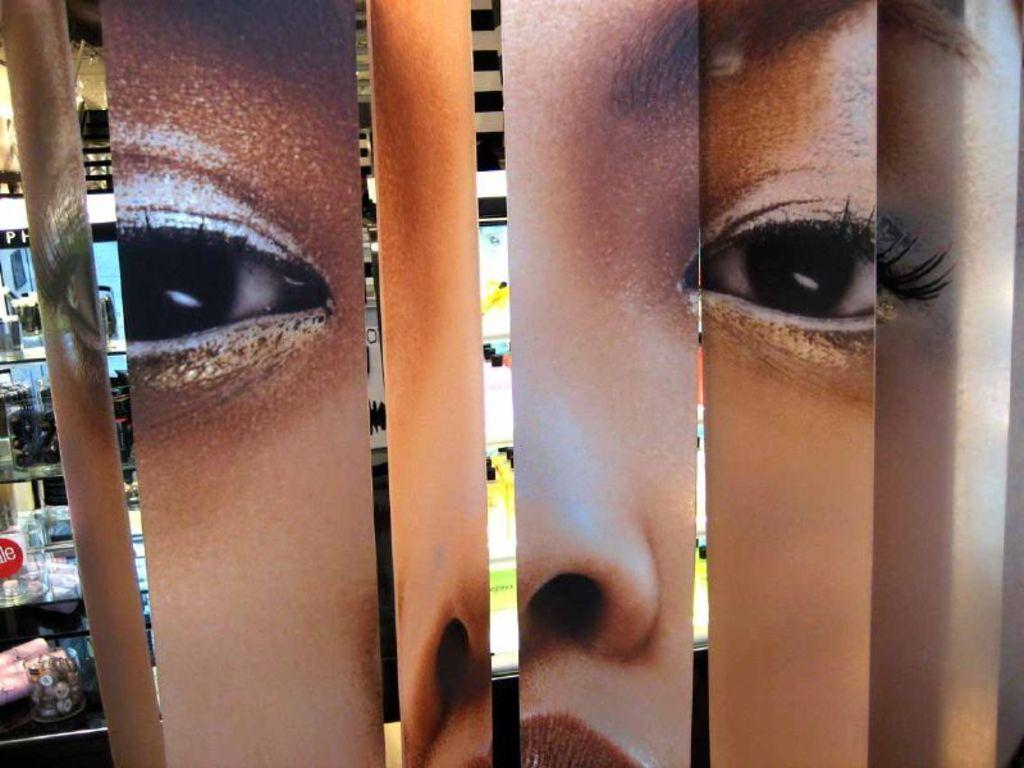What is the main subject of the image? The main subject of the image is an edited version of a person's face. Can you describe the background of the image? The background of the image resembles shelves with objects on them. What type of shoe can be seen on the chin of the person in the image? There is no shoe or chin visible in the image, as it is an edited version of a person's face with a background of shelves with objects on them. 